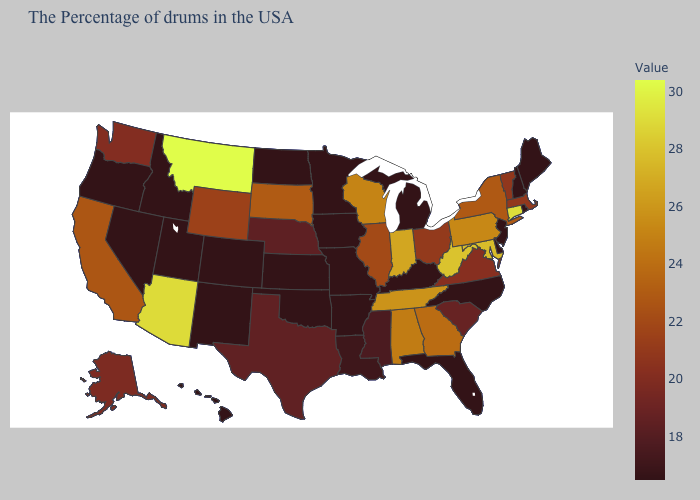Among the states that border Rhode Island , which have the highest value?
Short answer required. Connecticut. Which states have the lowest value in the MidWest?
Quick response, please. Michigan, Missouri, Minnesota, Iowa, Kansas, North Dakota. Which states have the lowest value in the South?
Quick response, please. Delaware, North Carolina, Florida, Kentucky, Arkansas, Oklahoma. Among the states that border Indiana , which have the highest value?
Concise answer only. Illinois. Among the states that border Vermont , which have the lowest value?
Keep it brief. New Hampshire. Among the states that border North Carolina , which have the lowest value?
Answer briefly. South Carolina. 